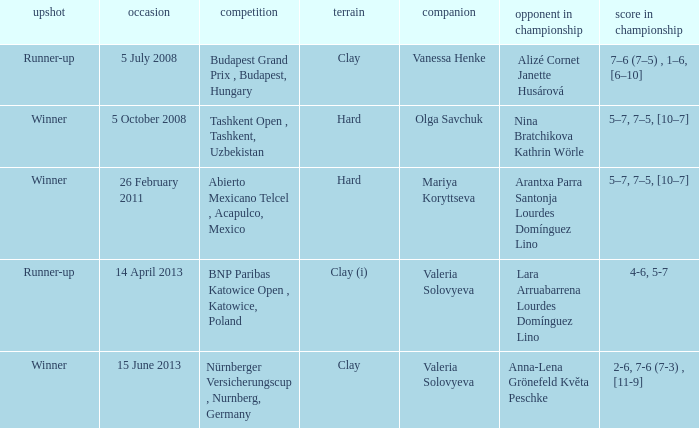Which partner was on 14 april 2013? Valeria Solovyeva. 